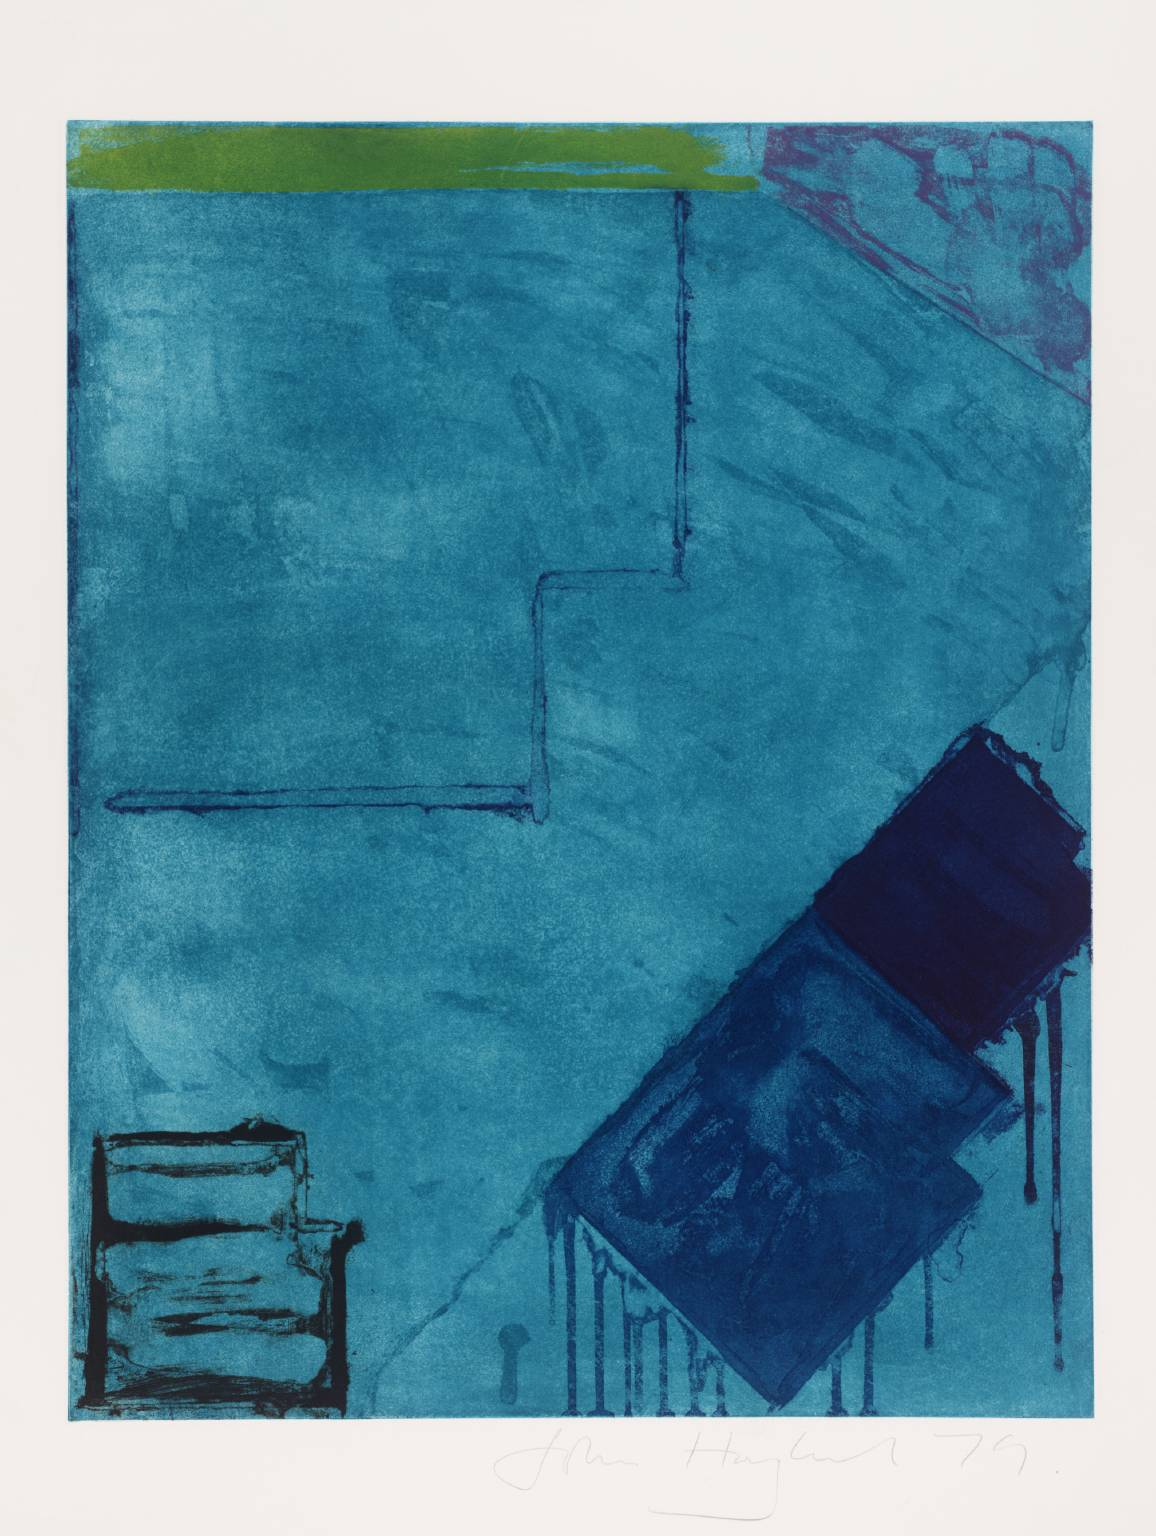What are the key elements in this picture? The image is a captivating example of abstract art, distinguished by its predominant use of various shades of blue, creating a visually harmonious and textured appearance. Notably, the picture features a striking green horizontal band at the top, which contrasts sharply with the blue, infusing the artwork with a bold dynamism. Additionally, a vivid pinkish-red streak on the right side breaks the continuity of the blue, drawing the eye and adding complexity. The composition includes geometric forms, such as a dark blue rectangle and a lighter blue square, which suggest an architectural influence or symbolic meaning. This abstract piece plays with color theory and composition to evoke emotion and provoke thought. 